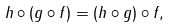Convert formula to latex. <formula><loc_0><loc_0><loc_500><loc_500>h \circ ( g \circ f ) = ( h \circ g ) \circ f ,</formula> 